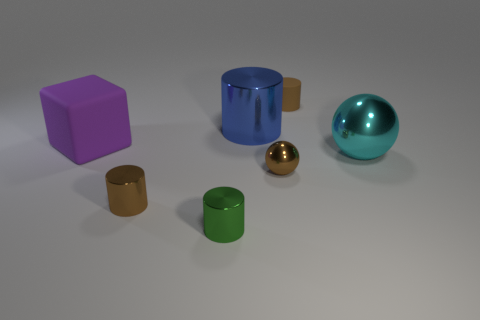Add 1 small shiny cylinders. How many objects exist? 8 Subtract all blue cylinders. How many cylinders are left? 3 Subtract all small green cylinders. How many cylinders are left? 3 Subtract all red cylinders. Subtract all cyan blocks. How many cylinders are left? 4 Subtract all balls. How many objects are left? 5 Subtract all brown rubber cylinders. Subtract all large metal spheres. How many objects are left? 5 Add 4 tiny cylinders. How many tiny cylinders are left? 7 Add 5 metallic blocks. How many metallic blocks exist? 5 Subtract 1 purple cubes. How many objects are left? 6 